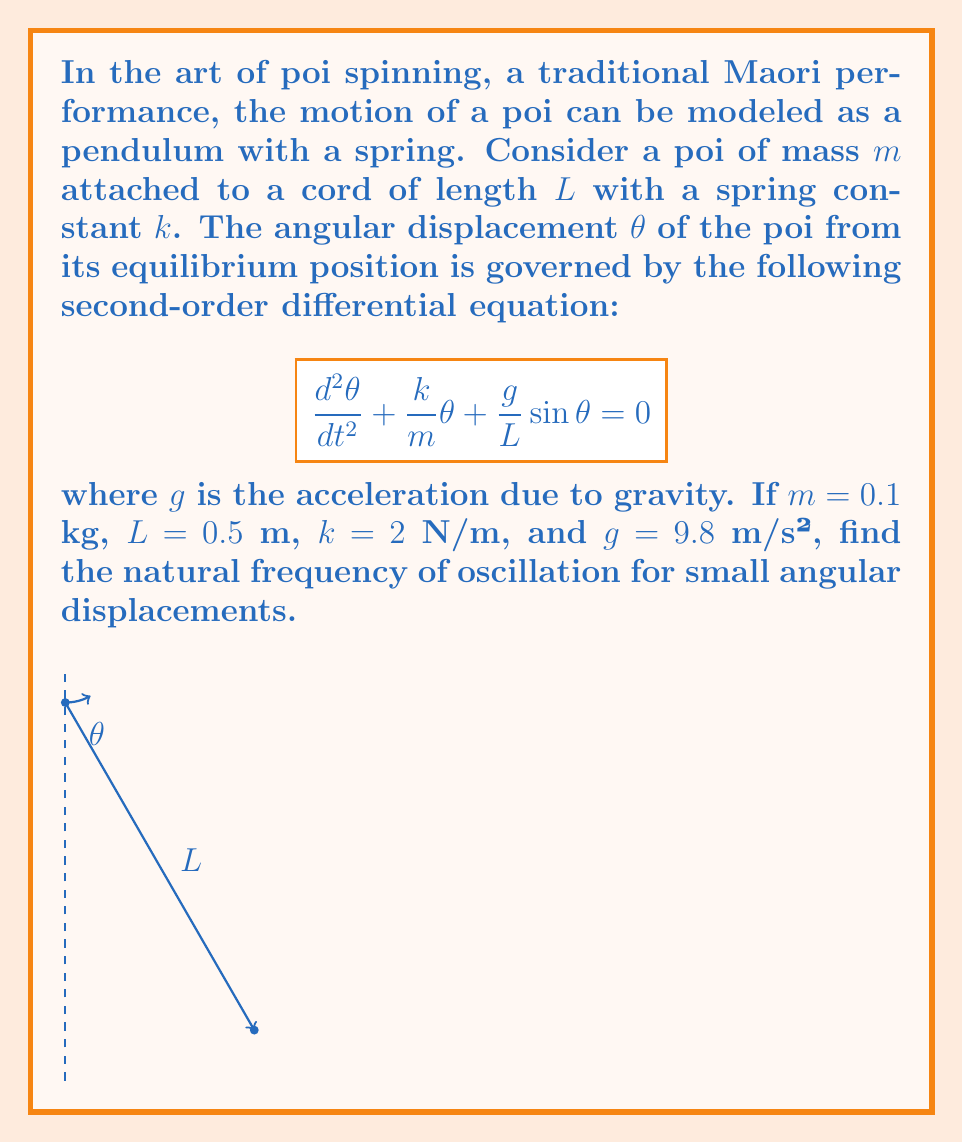Solve this math problem. To solve this problem, we'll follow these steps:

1) For small angular displacements, we can approximate $\sin\theta \approx \theta$. This simplifies our equation to:

   $$\frac{d^2\theta}{dt^2} + \frac{k}{m}\theta + \frac{g}{L}\theta = 0$$

2) Rearranging the terms:

   $$\frac{d^2\theta}{dt^2} + (\frac{k}{m} + \frac{g}{L})\theta = 0$$

3) This is in the form of a simple harmonic oscillator equation:

   $$\frac{d^2\theta}{dt^2} + \omega^2\theta = 0$$

   where $\omega$ is the natural angular frequency of oscillation.

4) By comparison, we can see that:

   $$\omega^2 = \frac{k}{m} + \frac{g}{L}$$

5) Substituting the given values:

   $$\omega^2 = \frac{2}{0.1} + \frac{9.8}{0.5} = 20 + 19.6 = 39.6$$

6) Taking the square root:

   $$\omega = \sqrt{39.6} \approx 6.29 \text{ rad/s}$$

7) The natural frequency $f$ is related to the angular frequency by $\omega = 2\pi f$. So:

   $$f = \frac{\omega}{2\pi} = \frac{6.29}{2\pi} \approx 1.00 \text{ Hz}$$
Answer: $1.00$ Hz 